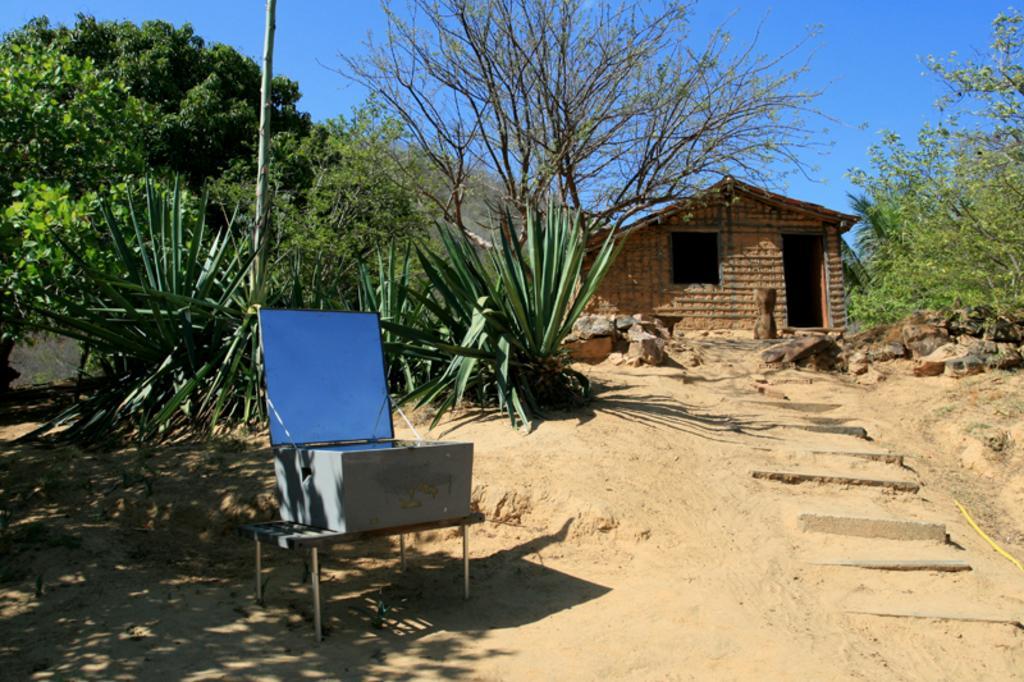Please provide a concise description of this image. In this image I can see the ground, few stairs, few trees which are green in color, a table and on the table I can see a box. I can see a house which is brown in color and in the background I can see the sky. 